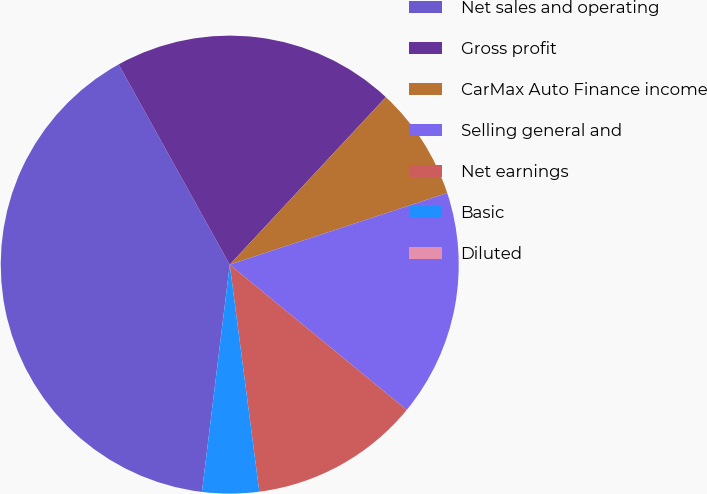<chart> <loc_0><loc_0><loc_500><loc_500><pie_chart><fcel>Net sales and operating<fcel>Gross profit<fcel>CarMax Auto Finance income<fcel>Selling general and<fcel>Net earnings<fcel>Basic<fcel>Diluted<nl><fcel>40.0%<fcel>20.0%<fcel>8.0%<fcel>16.0%<fcel>12.0%<fcel>4.0%<fcel>0.0%<nl></chart> 